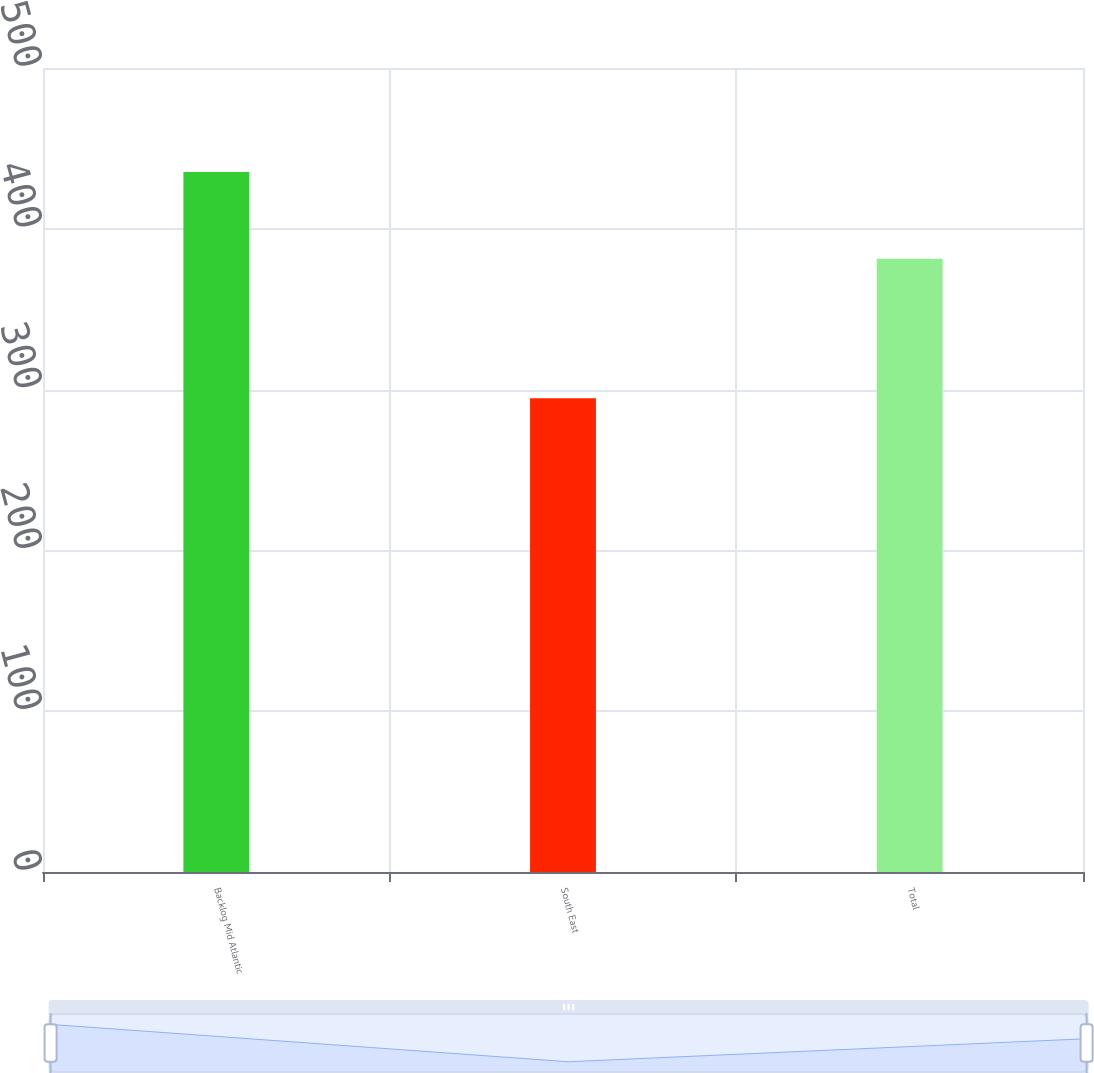Convert chart to OTSL. <chart><loc_0><loc_0><loc_500><loc_500><bar_chart><fcel>Backlog Mid Atlantic<fcel>South East<fcel>Total<nl><fcel>435.3<fcel>294.6<fcel>381.3<nl></chart> 